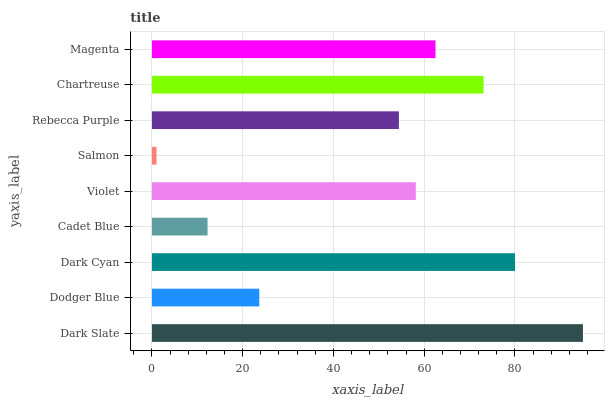Is Salmon the minimum?
Answer yes or no. Yes. Is Dark Slate the maximum?
Answer yes or no. Yes. Is Dodger Blue the minimum?
Answer yes or no. No. Is Dodger Blue the maximum?
Answer yes or no. No. Is Dark Slate greater than Dodger Blue?
Answer yes or no. Yes. Is Dodger Blue less than Dark Slate?
Answer yes or no. Yes. Is Dodger Blue greater than Dark Slate?
Answer yes or no. No. Is Dark Slate less than Dodger Blue?
Answer yes or no. No. Is Violet the high median?
Answer yes or no. Yes. Is Violet the low median?
Answer yes or no. Yes. Is Dark Slate the high median?
Answer yes or no. No. Is Magenta the low median?
Answer yes or no. No. 